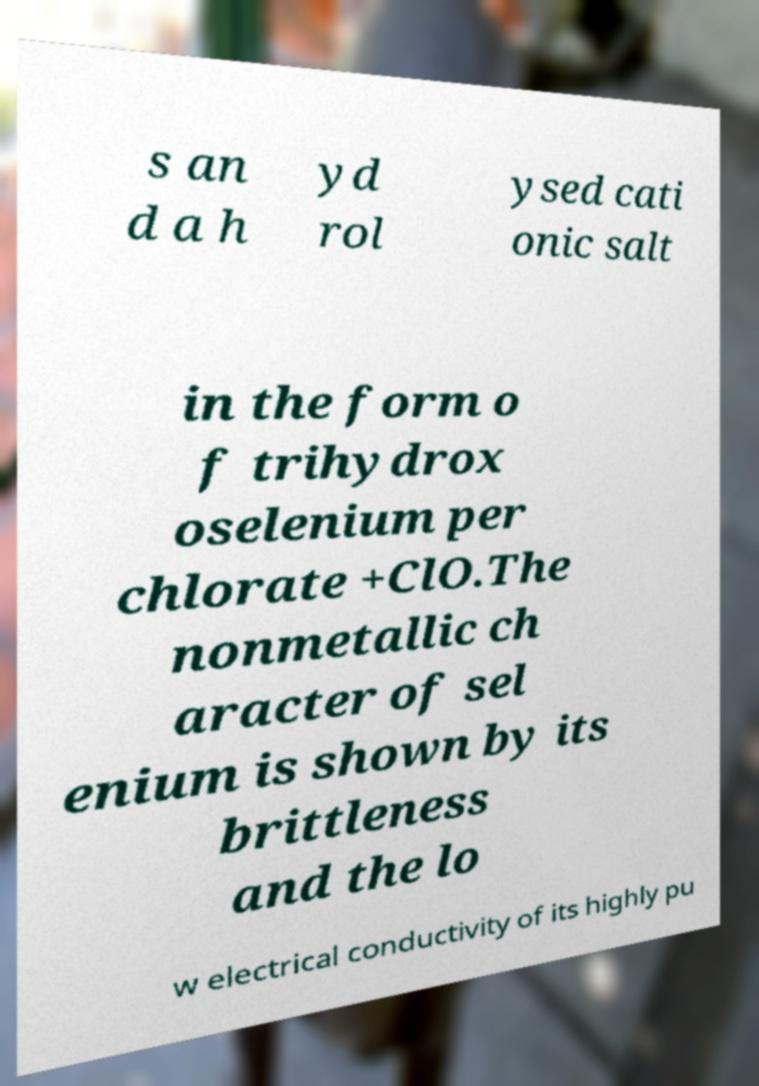There's text embedded in this image that I need extracted. Can you transcribe it verbatim? s an d a h yd rol ysed cati onic salt in the form o f trihydrox oselenium per chlorate +ClO.The nonmetallic ch aracter of sel enium is shown by its brittleness and the lo w electrical conductivity of its highly pu 